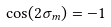Convert formula to latex. <formula><loc_0><loc_0><loc_500><loc_500>\cos ( 2 \sigma _ { m } ) = - 1</formula> 